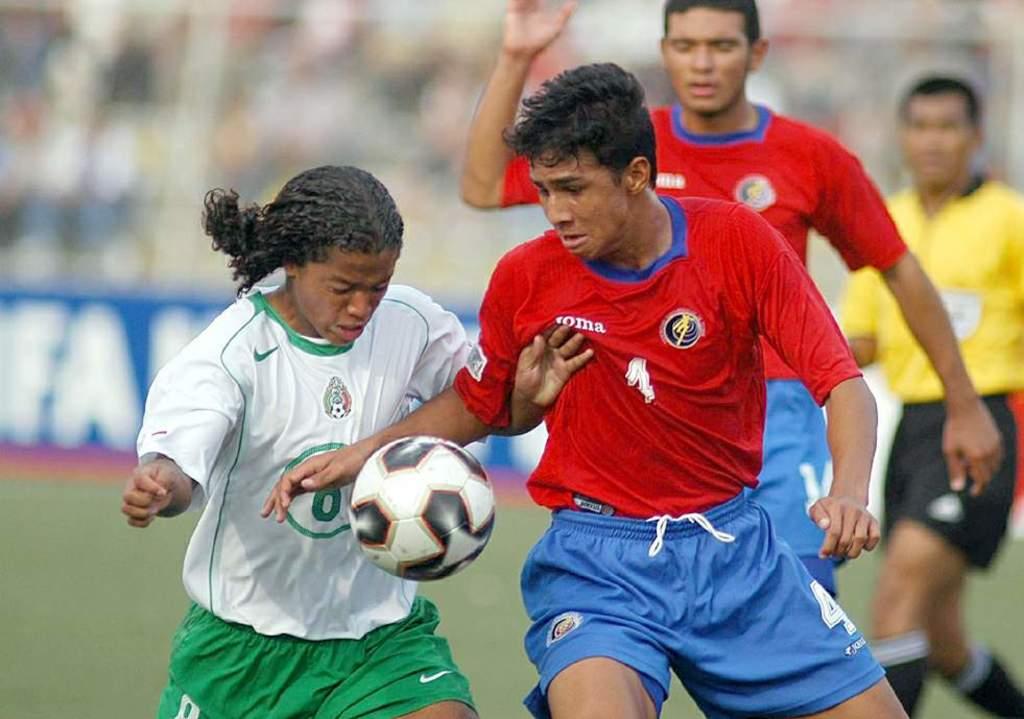Is player 4 in this?
Ensure brevity in your answer.  Yes. What is the last letter of the white text on the red jersey?
Your answer should be very brief. A. 